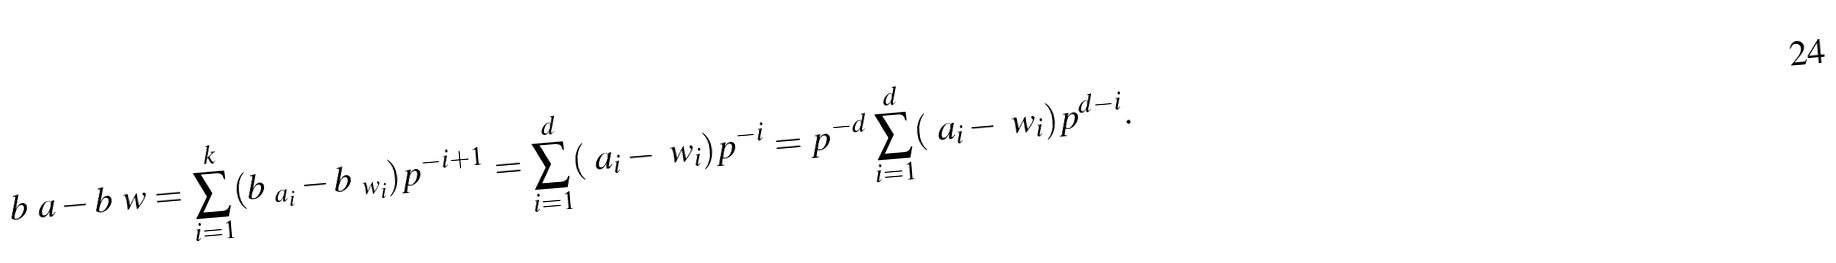Convert formula to latex. <formula><loc_0><loc_0><loc_500><loc_500>b _ { \ } a - b _ { \ } w = \sum _ { i = 1 } ^ { k } ( b _ { \ a _ { i } } - b _ { \ w _ { i } } ) p ^ { - i + 1 } = \sum _ { i = 1 } ^ { d } ( \ a _ { i } - \ w _ { i } ) p ^ { - i } = p ^ { - d } \sum _ { i = 1 } ^ { d } ( \ a _ { i } - \ w _ { i } ) p ^ { d - i } .</formula> 